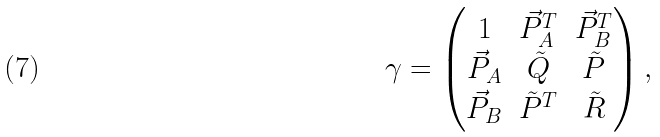<formula> <loc_0><loc_0><loc_500><loc_500>\gamma = \begin{pmatrix} 1 & \vec { P } _ { A } ^ { T } & \vec { P } _ { B } ^ { T } \\ \vec { P } _ { A } & \tilde { Q } & \tilde { P } \\ \vec { P } _ { B } & \tilde { P } ^ { T } & \tilde { R } \\ \end{pmatrix} ,</formula> 